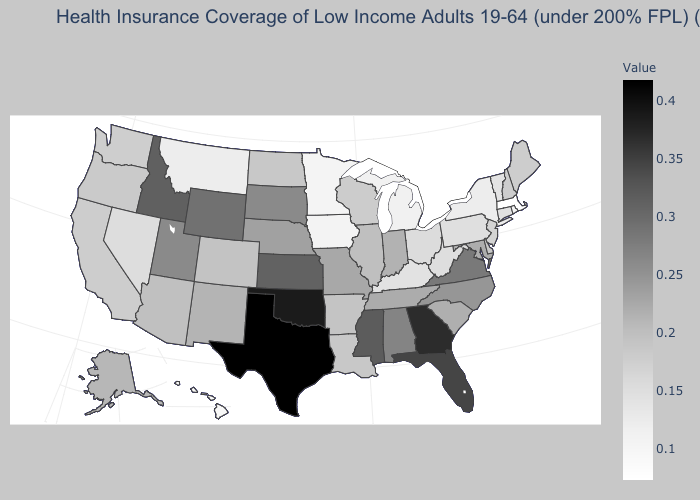Among the states that border Arkansas , which have the lowest value?
Give a very brief answer. Louisiana. Among the states that border Arkansas , which have the lowest value?
Give a very brief answer. Louisiana. Which states hav the highest value in the MidWest?
Short answer required. Kansas. Does Massachusetts have the lowest value in the USA?
Keep it brief. Yes. Which states hav the highest value in the West?
Keep it brief. Idaho. Does Kentucky have a lower value than Massachusetts?
Keep it brief. No. Among the states that border Wyoming , which have the highest value?
Short answer required. Idaho. Does the map have missing data?
Concise answer only. No. 